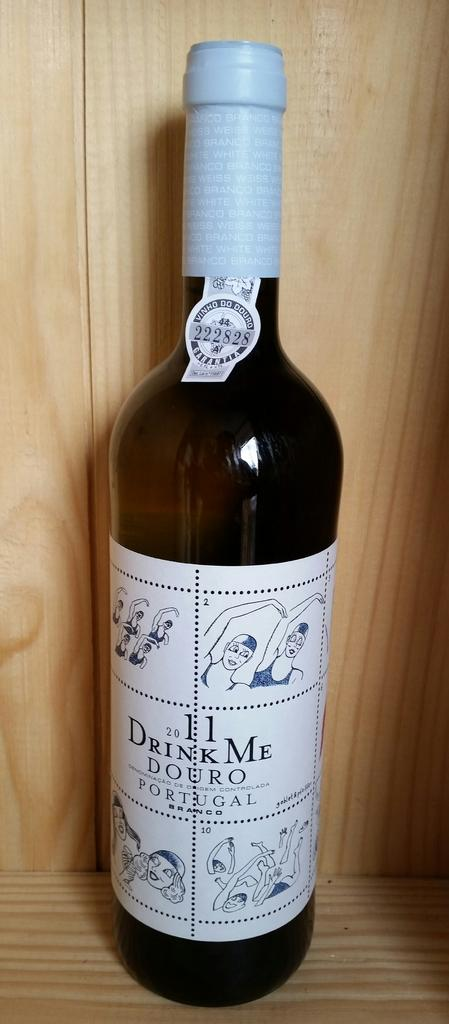<image>
Summarize the visual content of the image. A bottle of 2011 wine from Portugal on a wooden shelf. 